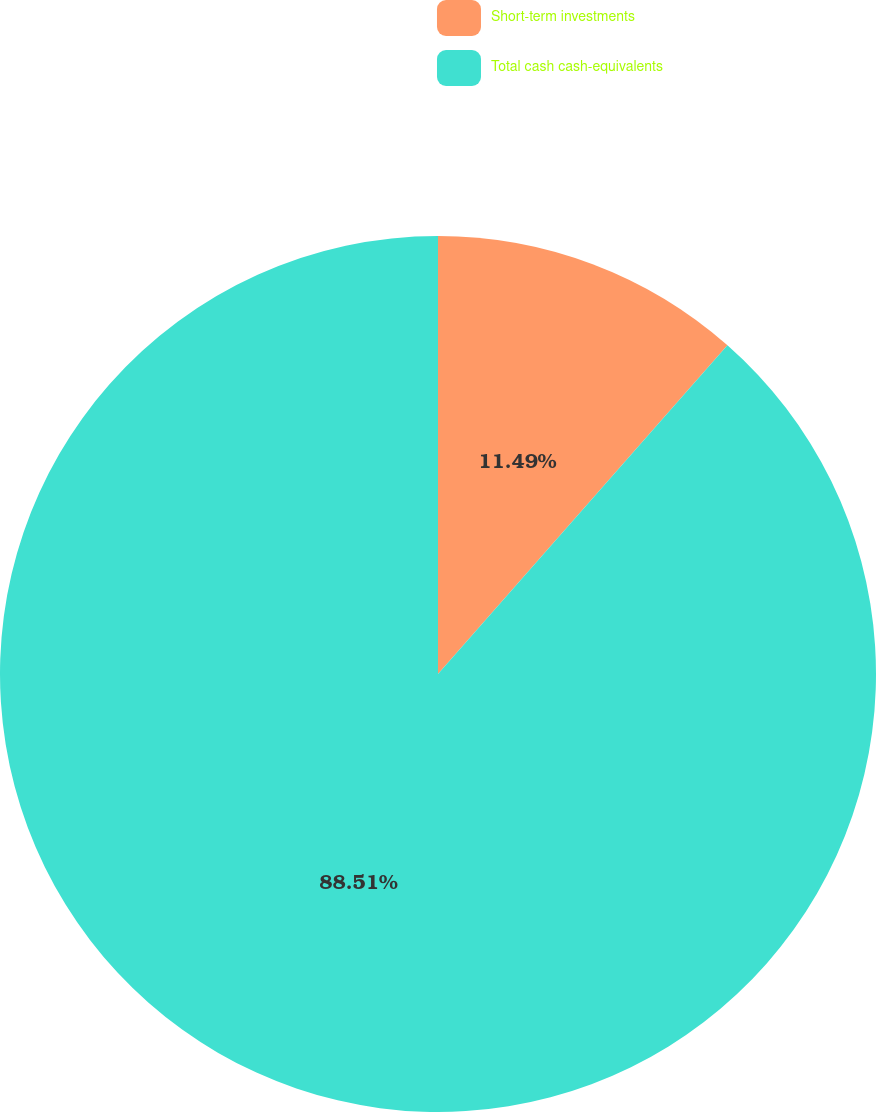Convert chart. <chart><loc_0><loc_0><loc_500><loc_500><pie_chart><fcel>Short-term investments<fcel>Total cash cash-equivalents<nl><fcel>11.49%<fcel>88.51%<nl></chart> 